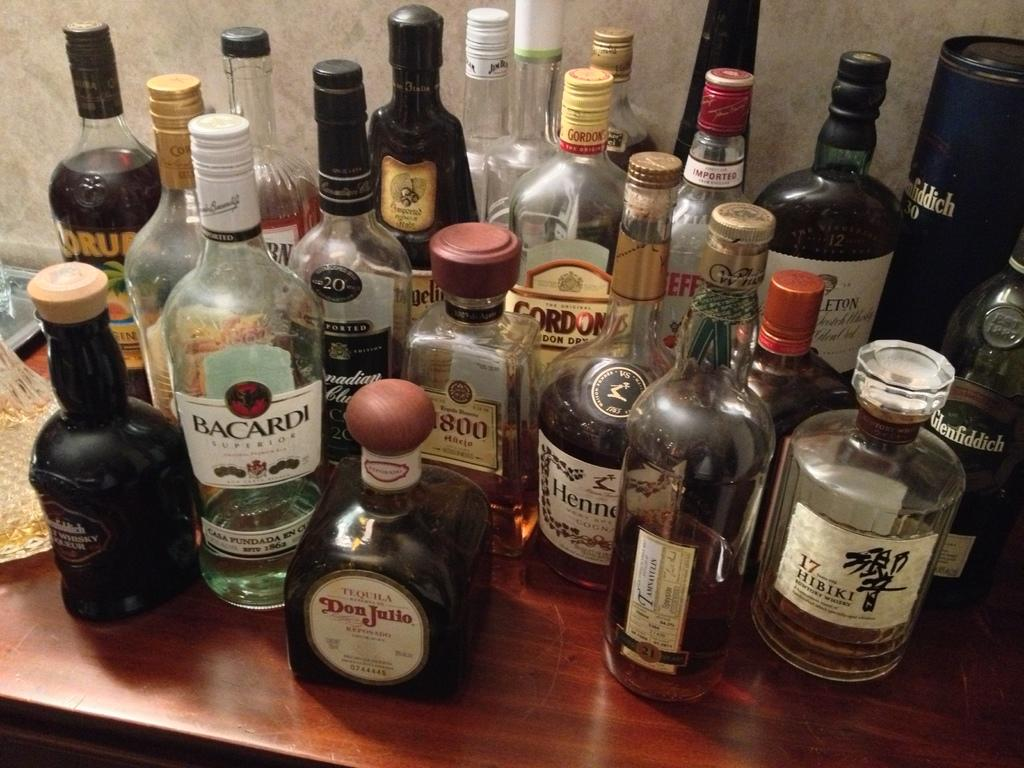<image>
Provide a brief description of the given image. the words don julio are on the front of the sauce 